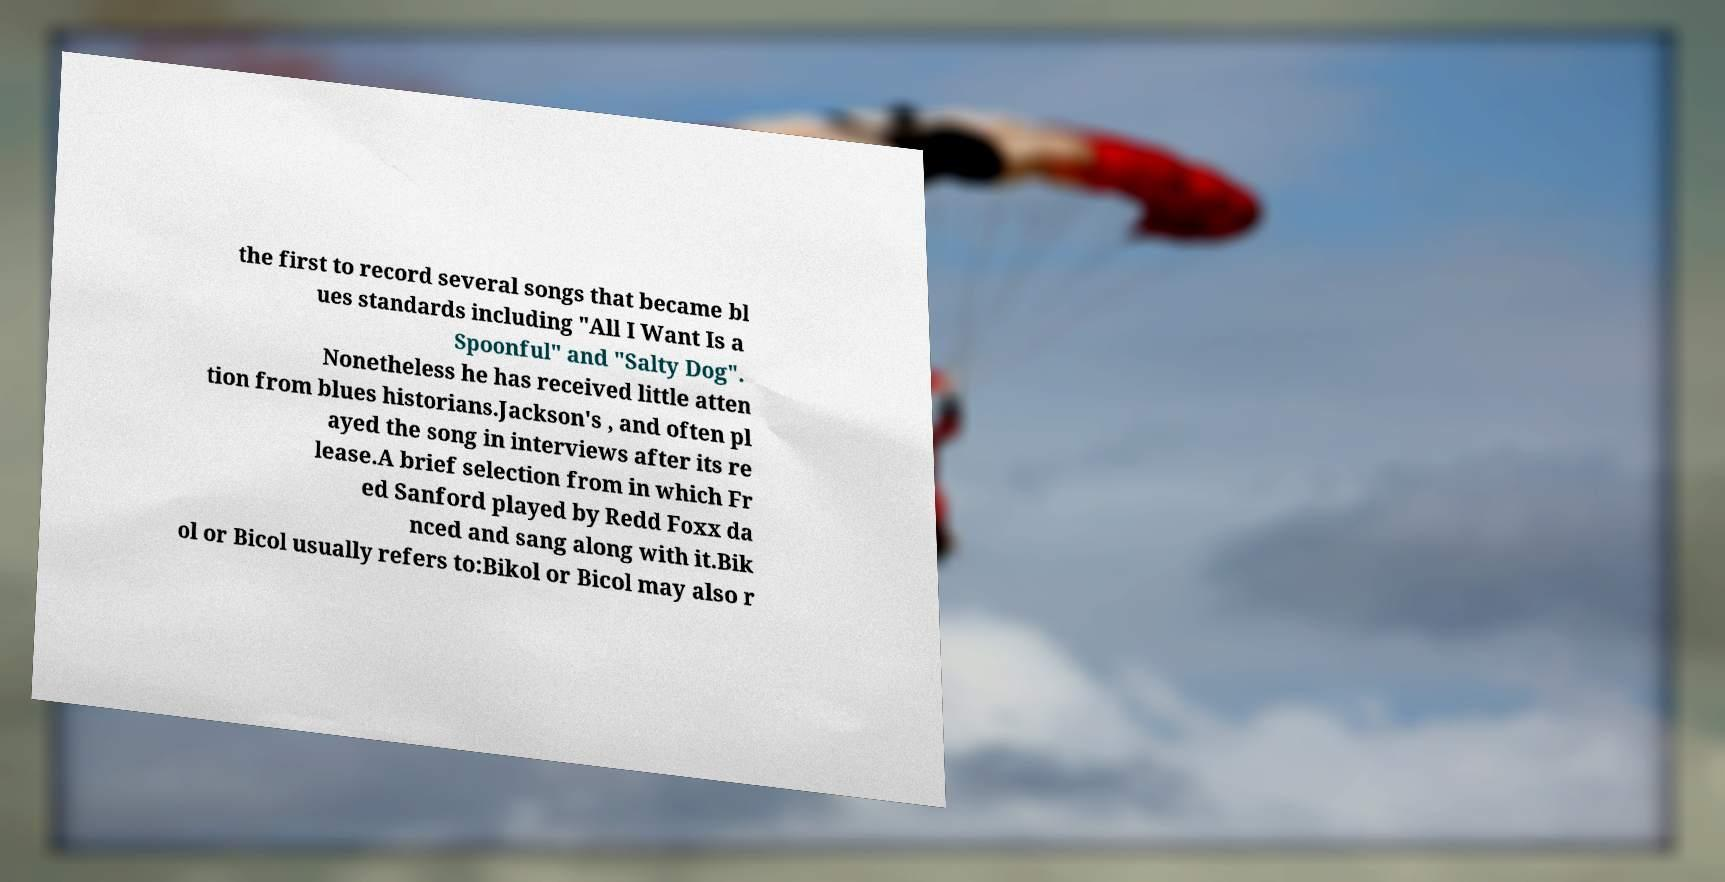What messages or text are displayed in this image? I need them in a readable, typed format. the first to record several songs that became bl ues standards including "All I Want Is a Spoonful" and "Salty Dog". Nonetheless he has received little atten tion from blues historians.Jackson's , and often pl ayed the song in interviews after its re lease.A brief selection from in which Fr ed Sanford played by Redd Foxx da nced and sang along with it.Bik ol or Bicol usually refers to:Bikol or Bicol may also r 